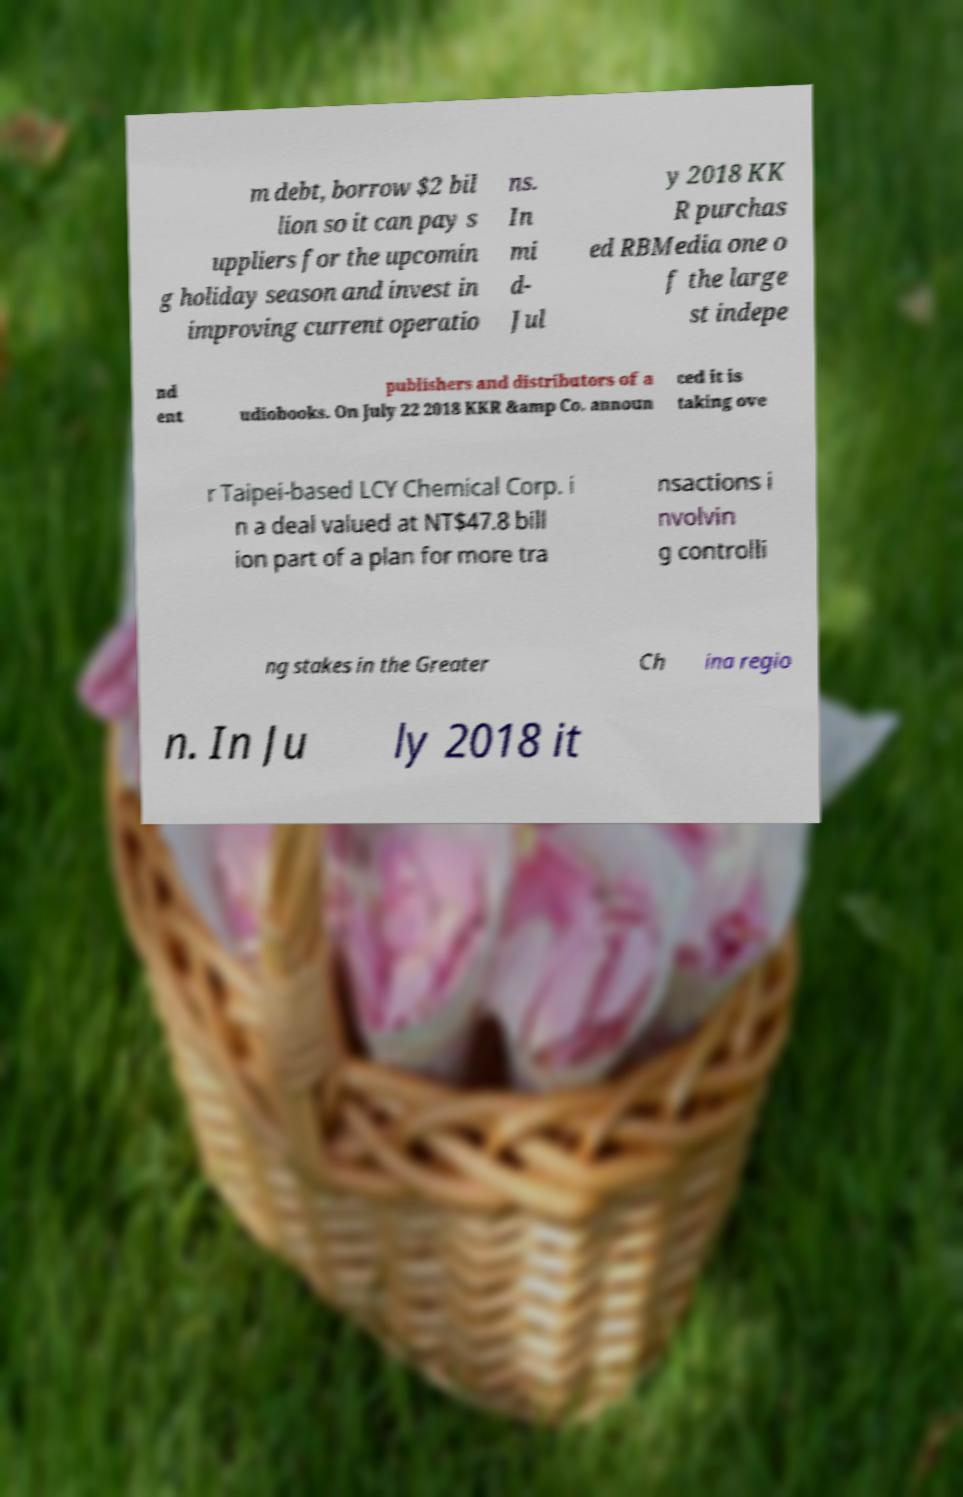Please read and relay the text visible in this image. What does it say? m debt, borrow $2 bil lion so it can pay s uppliers for the upcomin g holiday season and invest in improving current operatio ns. In mi d- Jul y 2018 KK R purchas ed RBMedia one o f the large st indepe nd ent publishers and distributors of a udiobooks. On July 22 2018 KKR &amp Co. announ ced it is taking ove r Taipei-based LCY Chemical Corp. i n a deal valued at NT$47.8 bill ion part of a plan for more tra nsactions i nvolvin g controlli ng stakes in the Greater Ch ina regio n. In Ju ly 2018 it 